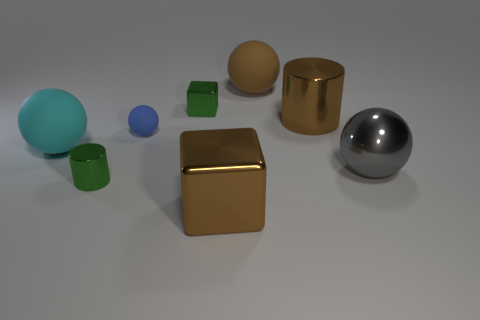Add 2 small green blocks. How many objects exist? 10 Add 7 small brown balls. How many small brown balls exist? 7 Subtract all brown cylinders. How many cylinders are left? 1 Subtract all large balls. How many balls are left? 1 Subtract 0 purple cubes. How many objects are left? 8 Subtract all cylinders. How many objects are left? 6 Subtract 1 balls. How many balls are left? 3 Subtract all green cubes. Subtract all yellow cylinders. How many cubes are left? 1 Subtract all purple cylinders. How many cyan blocks are left? 0 Subtract all gray metal balls. Subtract all large cylinders. How many objects are left? 6 